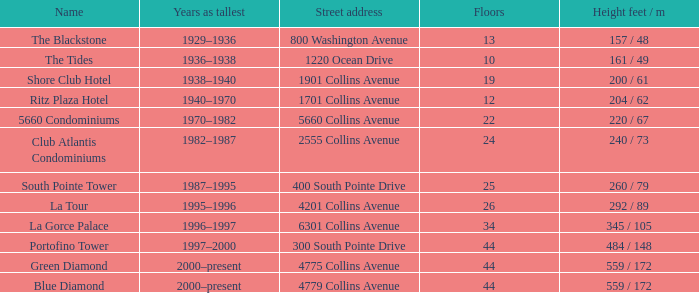For how long was the 24-story building the tallest? 1982–1987. 